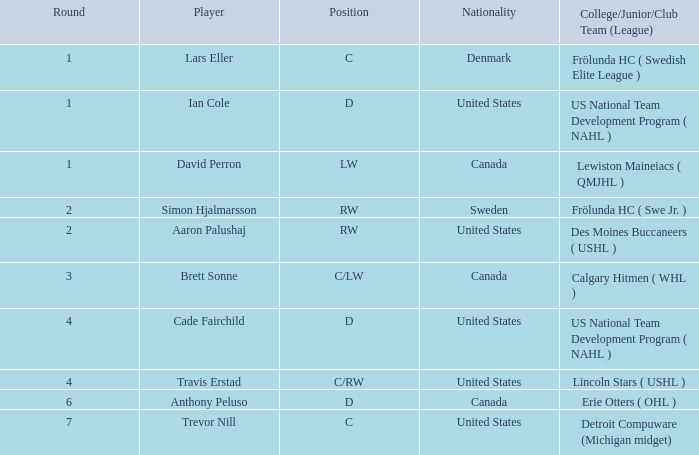For ian cole, a united states position d player, what was his highest round? 1.0. 